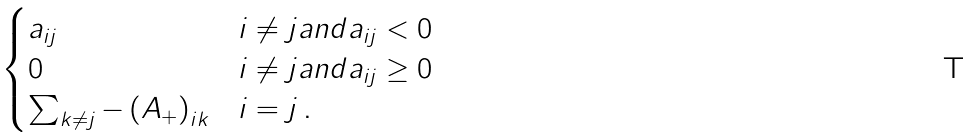Convert formula to latex. <formula><loc_0><loc_0><loc_500><loc_500>\begin{cases} a _ { i j } & i \neq j a n d a _ { i j } < 0 \\ 0 & i \neq j a n d a _ { i j } \geq 0 \\ \sum _ { k \neq j } - \left ( A _ { + } \right ) _ { i k } & i = j \, . \end{cases}</formula> 